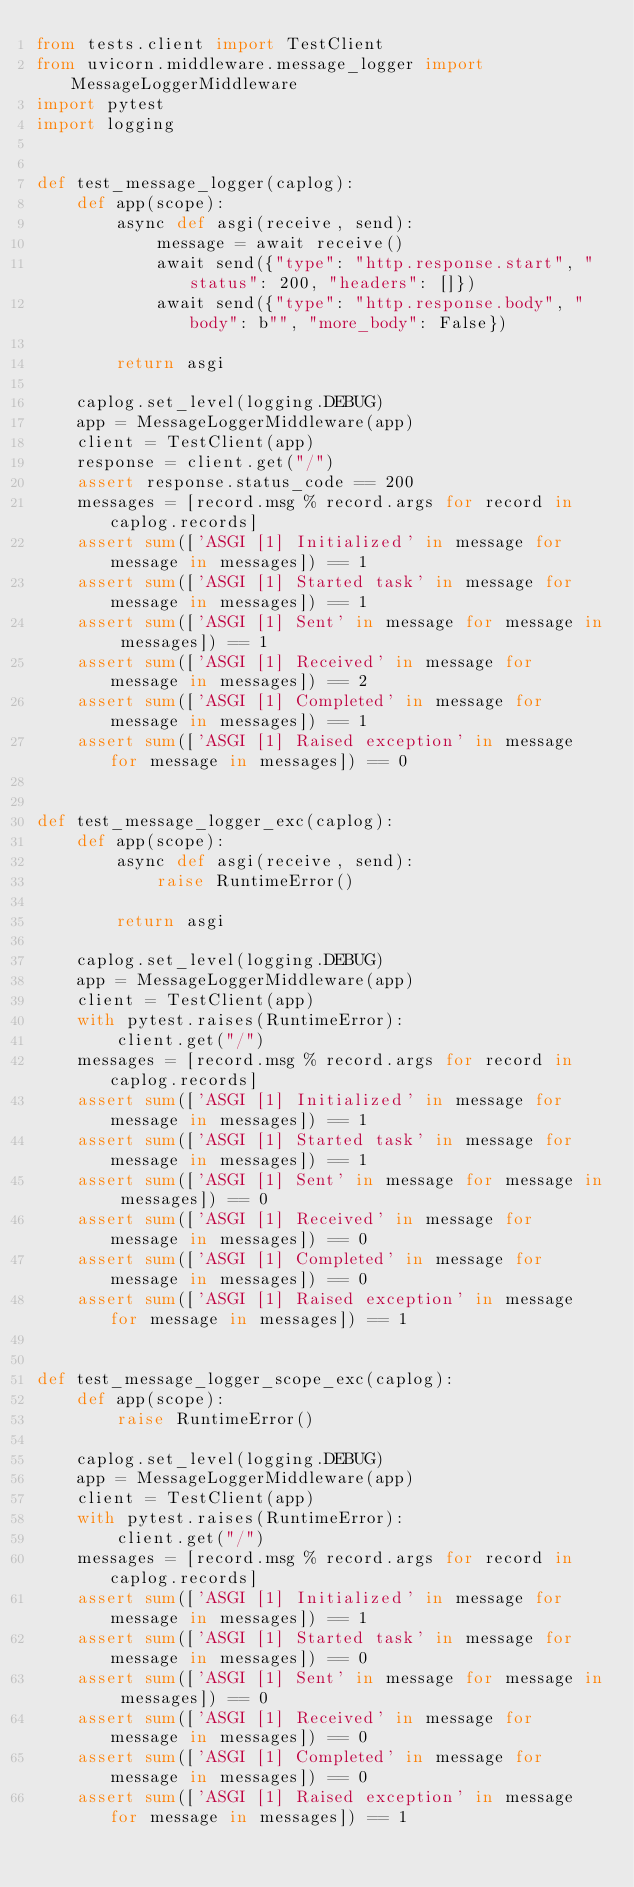<code> <loc_0><loc_0><loc_500><loc_500><_Python_>from tests.client import TestClient
from uvicorn.middleware.message_logger import MessageLoggerMiddleware
import pytest
import logging


def test_message_logger(caplog):
    def app(scope):
        async def asgi(receive, send):
            message = await receive()
            await send({"type": "http.response.start", "status": 200, "headers": []})
            await send({"type": "http.response.body", "body": b"", "more_body": False})

        return asgi

    caplog.set_level(logging.DEBUG)
    app = MessageLoggerMiddleware(app)
    client = TestClient(app)
    response = client.get("/")
    assert response.status_code == 200
    messages = [record.msg % record.args for record in caplog.records]
    assert sum(['ASGI [1] Initialized' in message for message in messages]) == 1
    assert sum(['ASGI [1] Started task' in message for message in messages]) == 1
    assert sum(['ASGI [1] Sent' in message for message in messages]) == 1
    assert sum(['ASGI [1] Received' in message for message in messages]) == 2
    assert sum(['ASGI [1] Completed' in message for message in messages]) == 1
    assert sum(['ASGI [1] Raised exception' in message for message in messages]) == 0


def test_message_logger_exc(caplog):
    def app(scope):
        async def asgi(receive, send):
            raise RuntimeError()

        return asgi

    caplog.set_level(logging.DEBUG)
    app = MessageLoggerMiddleware(app)
    client = TestClient(app)
    with pytest.raises(RuntimeError):
        client.get("/")
    messages = [record.msg % record.args for record in caplog.records]
    assert sum(['ASGI [1] Initialized' in message for message in messages]) == 1
    assert sum(['ASGI [1] Started task' in message for message in messages]) == 1
    assert sum(['ASGI [1] Sent' in message for message in messages]) == 0
    assert sum(['ASGI [1] Received' in message for message in messages]) == 0
    assert sum(['ASGI [1] Completed' in message for message in messages]) == 0
    assert sum(['ASGI [1] Raised exception' in message for message in messages]) == 1


def test_message_logger_scope_exc(caplog):
    def app(scope):
        raise RuntimeError()

    caplog.set_level(logging.DEBUG)
    app = MessageLoggerMiddleware(app)
    client = TestClient(app)
    with pytest.raises(RuntimeError):
        client.get("/")
    messages = [record.msg % record.args for record in caplog.records]
    assert sum(['ASGI [1] Initialized' in message for message in messages]) == 1
    assert sum(['ASGI [1] Started task' in message for message in messages]) == 0
    assert sum(['ASGI [1] Sent' in message for message in messages]) == 0
    assert sum(['ASGI [1] Received' in message for message in messages]) == 0
    assert sum(['ASGI [1] Completed' in message for message in messages]) == 0
    assert sum(['ASGI [1] Raised exception' in message for message in messages]) == 1
</code> 